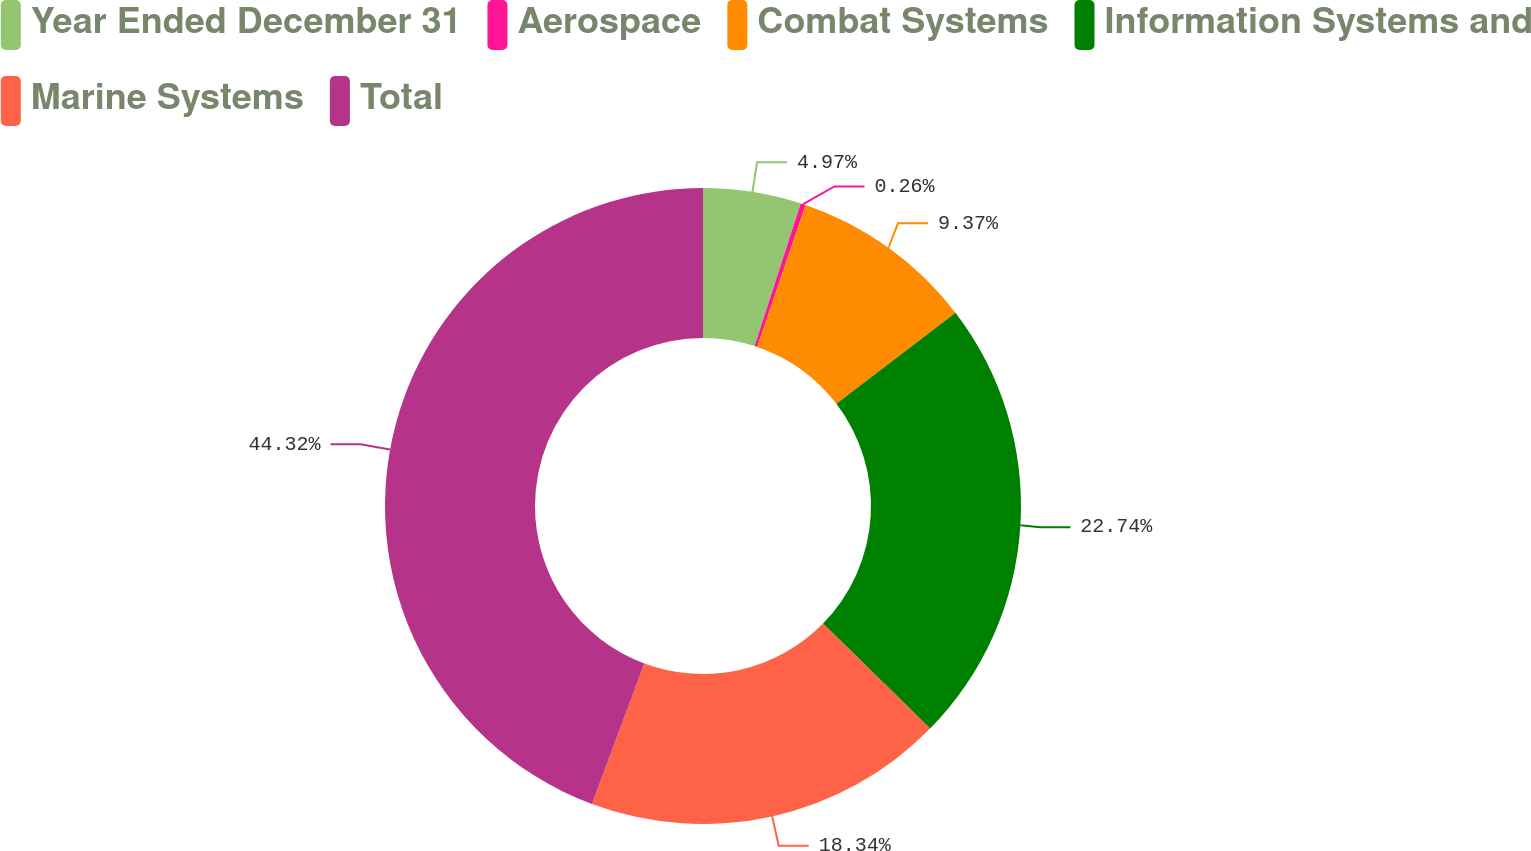Convert chart to OTSL. <chart><loc_0><loc_0><loc_500><loc_500><pie_chart><fcel>Year Ended December 31<fcel>Aerospace<fcel>Combat Systems<fcel>Information Systems and<fcel>Marine Systems<fcel>Total<nl><fcel>4.97%<fcel>0.26%<fcel>9.37%<fcel>22.74%<fcel>18.34%<fcel>44.32%<nl></chart> 